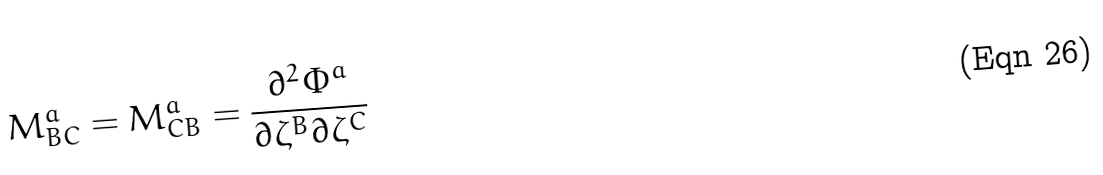<formula> <loc_0><loc_0><loc_500><loc_500>M _ { B C } ^ { a } = M _ { C B } ^ { a } = \frac { \partial ^ { 2 } \Phi ^ { a } } { \partial \zeta ^ { B } \partial \zeta ^ { C } }</formula> 